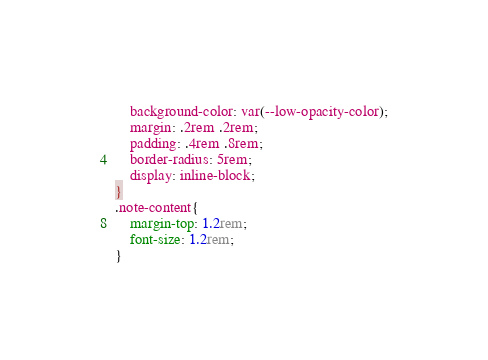Convert code to text. <code><loc_0><loc_0><loc_500><loc_500><_CSS_>    background-color: var(--low-opacity-color);
    margin: .2rem .2rem;
    padding: .4rem .8rem;
    border-radius: 5rem;
    display: inline-block;
}
.note-content{
    margin-top: 1.2rem;
    font-size: 1.2rem;
}</code> 